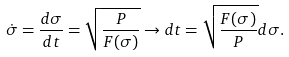<formula> <loc_0><loc_0><loc_500><loc_500>\dot { \sigma } = \frac { d \sigma } { d t } = \sqrt { \frac { P } { F ( \sigma ) } } \to d t = \sqrt { \frac { F ( \sigma ) } { P } } d \sigma .</formula> 